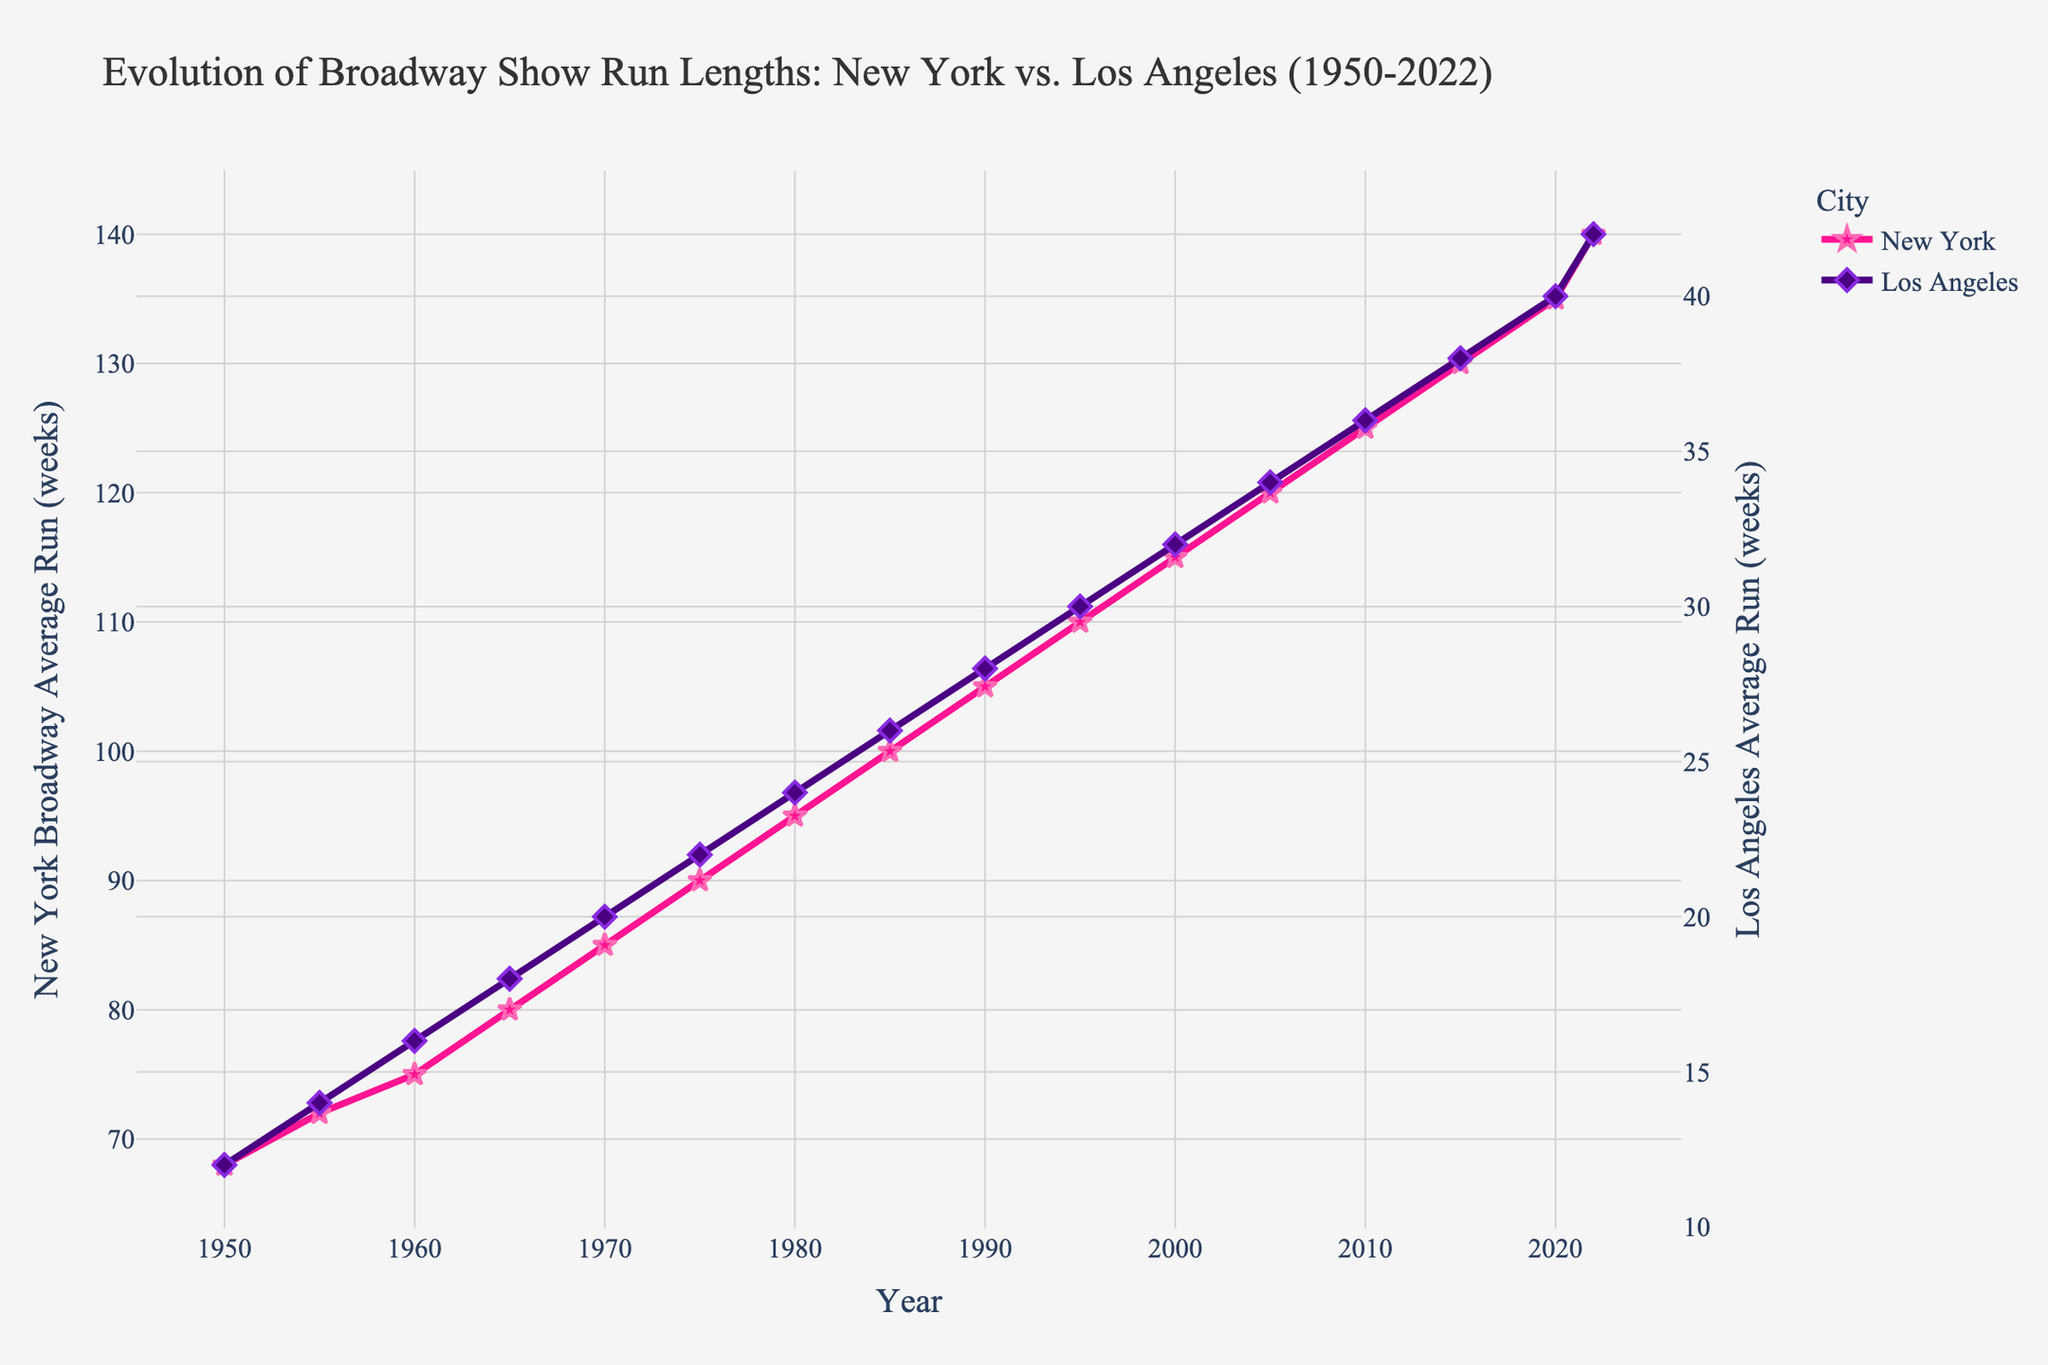What is the difference in average run length between New York and Los Angeles in 2022? Look at the figure and find the corresponding run lengths for 2022. New York is at 140 weeks and Los Angeles is at 42 weeks. The difference is 140 - 42 = 98 weeks.
Answer: 98 weeks Which year saw the largest gap between the average run lengths of New York and Los Angeles? To find this, calculate the difference between New York and Los Angeles for each year and identify the year with the largest difference. The largest gap appears in 2022 with a difference of 98 weeks.
Answer: 2022 How has the average run length for Broadway shows in Los Angeles changed from 1950 to 2022? Look at the starting point in 1950 and the endpoint in 2022 for Los Angeles. The run length increased from 12 weeks in 1950 to 42 weeks in 2022. The overall increase is 42 - 12 = 30 weeks.
Answer: Increased by 30 weeks What was the average run length for New York Broadway shows in the year 2000? Find the corresponding data point in the figure for New York in the year 2000, which indicates 115 weeks.
Answer: 115 weeks Which city had the higher average run length for Broadway shows in 1970? Compare the data points for New York and Los Angeles in 1970. New York had 85 weeks, and Los Angeles had 20 weeks. New York had the higher run length.
Answer: New York What is the general trend observed for the average run lengths of Broadway shows in both New York and Los Angeles from 1950 to 2022? Examine the overall direction and shape of both lines in the figure. Both lines steadily increase, indicating an upward trend in average run lengths in both cities.
Answer: Upward trend What are the average run lengths for New York Broadway shows in 1955 and 1985, and how do they compare? Look at the specific data points in the figure for New York in 1955 and 1985, which are 72 weeks and 100 weeks, respectively. To compare, note that 100 - 72 = 28 weeks. Hence, the run length increased by 28 weeks from 1955 to 1985.
Answer: 1955: 72 weeks, 1985: 100 weeks, increased by 28 weeks By how many weeks did the average run length for Los Angeles increase between the years 1975 and 2005? Locate the run length values for Los Angeles in 1975 (22 weeks) and 2005 (34 weeks). The increase can be found as 34 - 22 = 12 weeks.
Answer: 12 weeks In which decade did New York see the most significant increase in the average run length of Broadway shows? Observe the differences in run lengths for New York at the beginning and end of each decade. The most significant increase occurs between 2010 and 2020, with an increase from 125 weeks to 140 weeks, which is a 15-week rise.
Answer: 2010-2020 